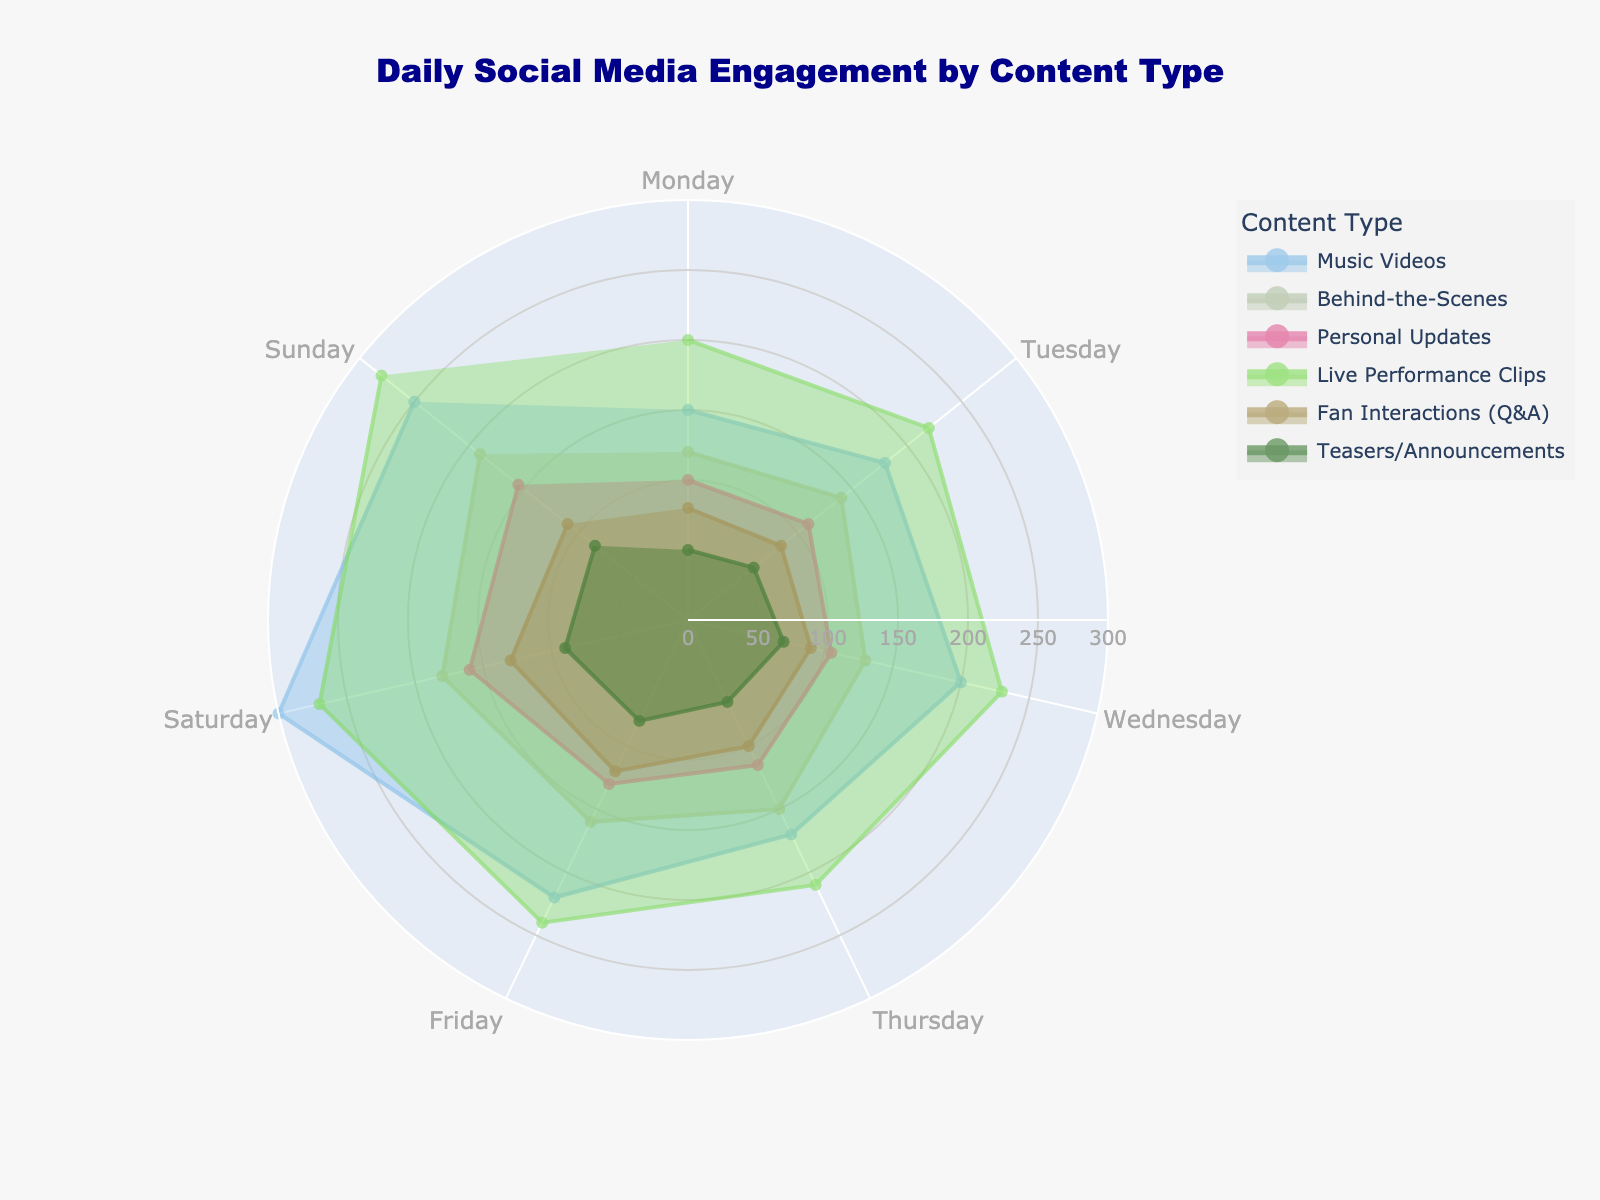Which day has the highest engagement for Music Videos? From the plot, the highest point on the Music Videos curve corresponds to Saturday. This can be seen as the largest radius in the Saturday segment of the rose chart.
Answer: Saturday What is the overall trend of social media engagement for Behind-the-Scenes content over the week? By following the Behind-the-Scenes trace from Monday to Sunday, you can observe a generally upward trend. This is indicated by the increasing radius from Monday (120) to Sunday (190).
Answer: Increasing How does the engagement for Live Performance Clips on Wednesday compare to that on Friday? Look at the radii for Live Performance Clips on Wednesday (230) and Friday (240). Comparing the two, Friday has a slightly higher engagement than Wednesday.
Answer: Higher on Friday What’s the average engagement for Personal Updates over the week? Sum the values for Personal Updates (100 + 110 + 105 + 115 + 130 + 160 + 155) to get 875. Divide by the number of days (7) to find the average: 875 / 7 = 125
Answer: 125 On which day is the engagement for Fan Interactions (Q&A) the lowest? The point with the smallest radius in the Fan Interactions trace can be seen on Monday, with an engagement value of 80.
Answer: Monday How does the engagement for Teasers/Announcements on Sunday compare to that on Thursday? Teasers/Announcements on Sunday has a value of 85 while on Thursday it has a value of 65. Sunday’s engagement is higher.
Answer: Higher on Sunday Which content type has the least daily engagement on average? Calculate the averages for each content type. Teasers/Announcements have the lowest weekly total engagement: (50 + 60 + 70 + 65 + 80 + 90 + 85) = 500. Divide by 7, yielding approximately 71.43, which is the lowest compared to other content types.
Answer: Teasers/Announcements On which day is the difference in engagement between Music Videos and Fan Interactions the greatest? Calculate the difference for each day and find the maximum:
Monday: 150 - 80 = 70
Tuesday: 180 - 85 = 95
Wednesday: 200 - 90 = 110
Thursday: 170 - 100 = 70
Friday: 220 - 120 = 100
Saturday: 300 - 130 = 170
Sunday: 250 - 110 = 140
The greatest difference is on Saturday (300 - 130 = 170).
Answer: Saturday 